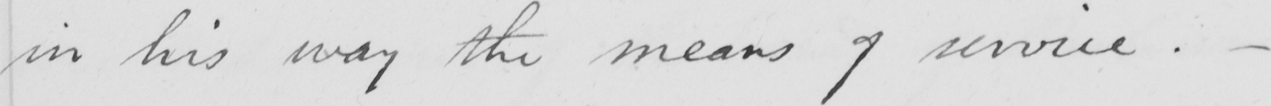What is written in this line of handwriting? in his way the means of service .  _ 